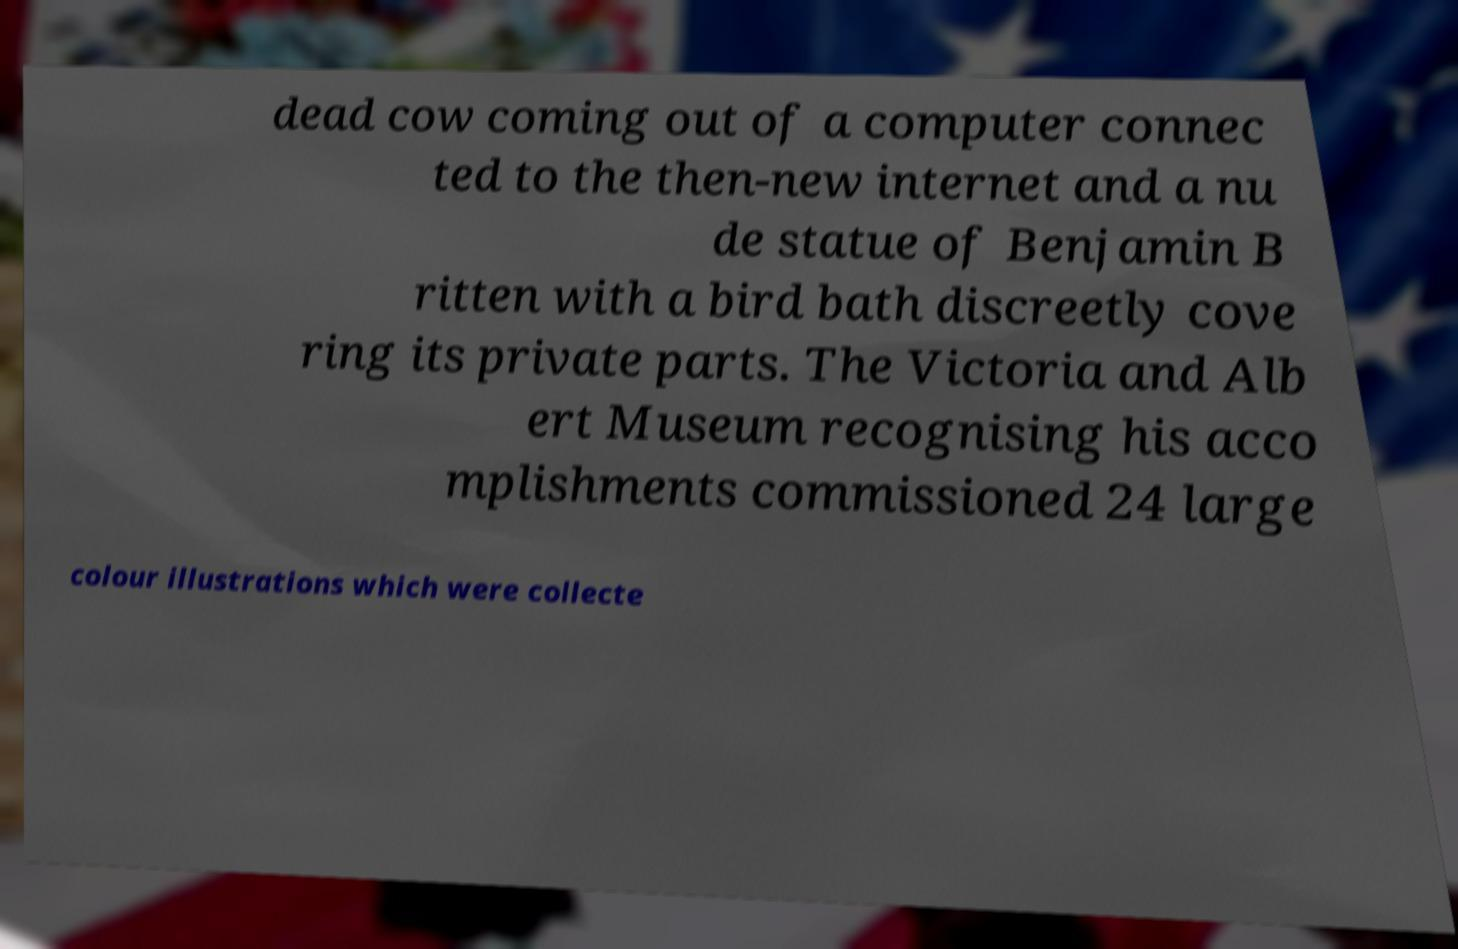Please identify and transcribe the text found in this image. dead cow coming out of a computer connec ted to the then-new internet and a nu de statue of Benjamin B ritten with a bird bath discreetly cove ring its private parts. The Victoria and Alb ert Museum recognising his acco mplishments commissioned 24 large colour illustrations which were collecte 